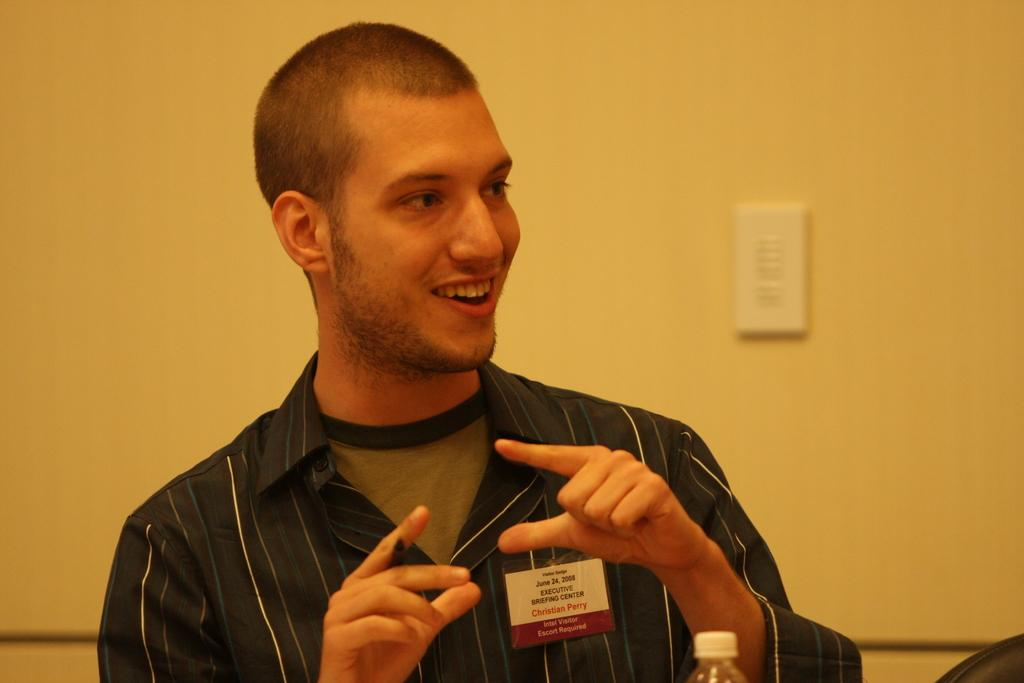Who is present in the image? There is a man in the image. What is the man's facial expression? The man is smiling. What object is in front of the man? There is a bottle in front of the man. What type of meat is the man cutting with the blade in the image? There is no blade or meat present in the image; it only features a man smiling with a bottle in front of him. 